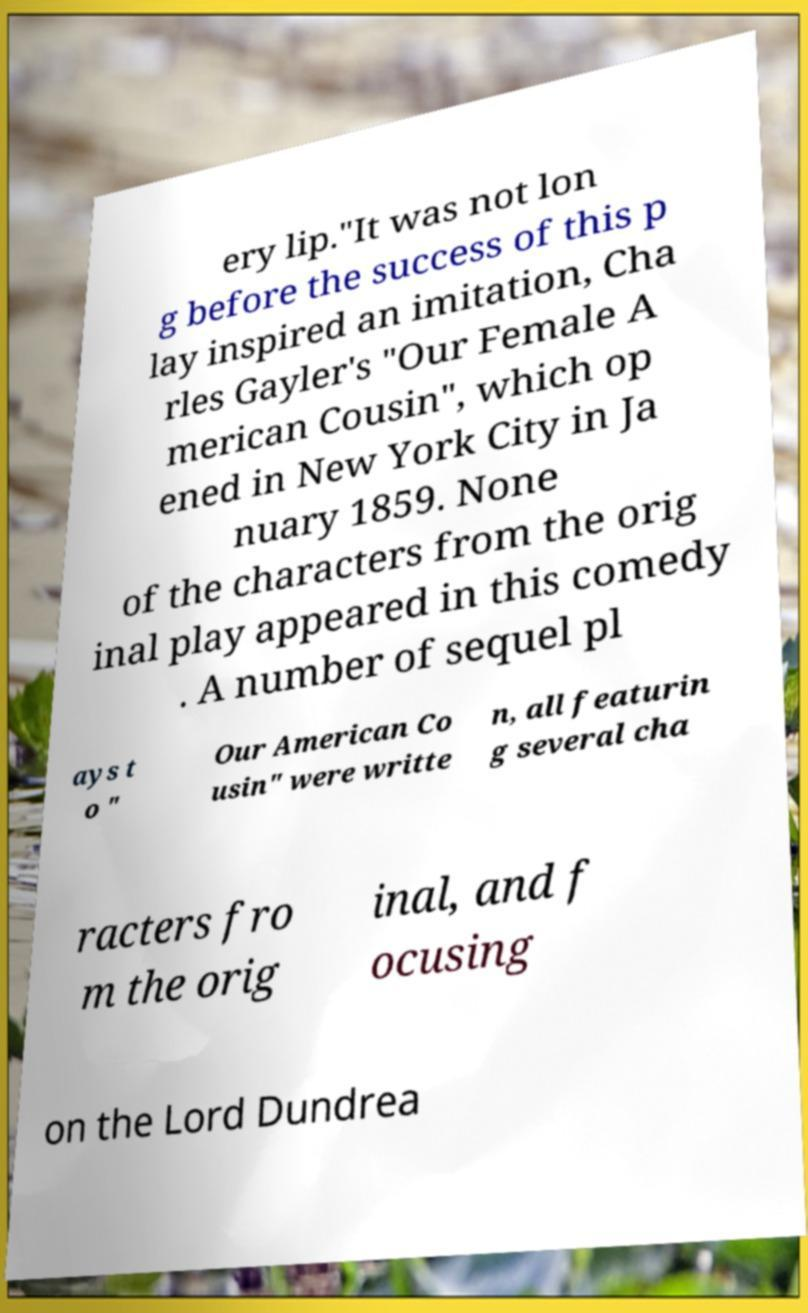I need the written content from this picture converted into text. Can you do that? ery lip."It was not lon g before the success of this p lay inspired an imitation, Cha rles Gayler's "Our Female A merican Cousin", which op ened in New York City in Ja nuary 1859. None of the characters from the orig inal play appeared in this comedy . A number of sequel pl ays t o " Our American Co usin" were writte n, all featurin g several cha racters fro m the orig inal, and f ocusing on the Lord Dundrea 